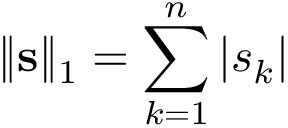<formula> <loc_0><loc_0><loc_500><loc_500>\| s \| _ { 1 } = \sum _ { k = 1 } ^ { n } \left | s _ { k } \right |</formula> 